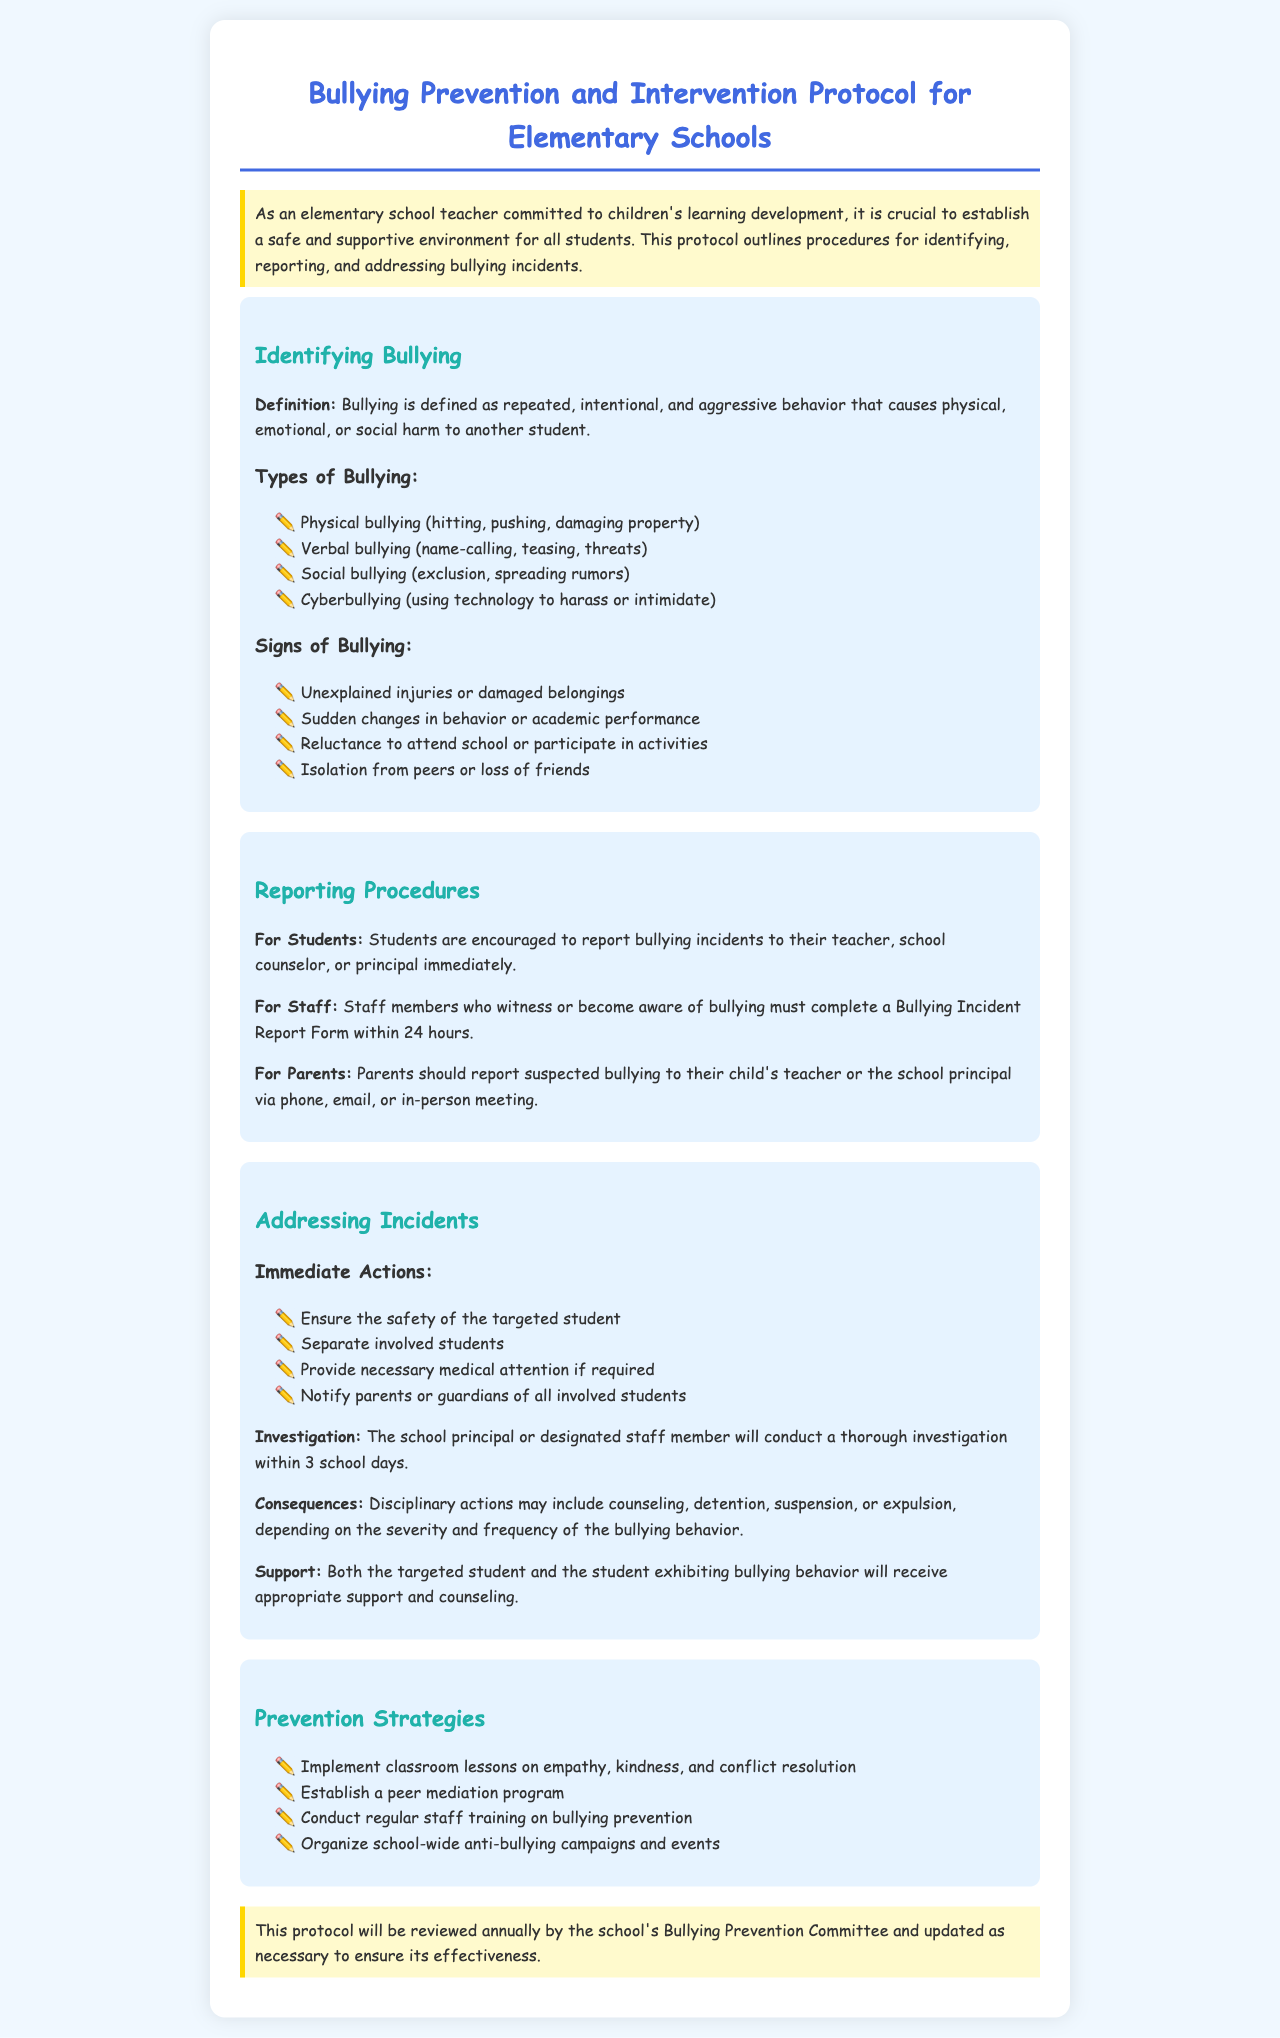What is the definition of bullying? The definition of bullying is stated in the document, highlighting that it involves repeated, intentional, and aggressive behavior causing harm to another student.
Answer: Repeated, intentional, and aggressive behavior What are the four types of bullying listed? The document specifies four types of bullying that need to be recognized.
Answer: Physical, verbal, social, cyberbullying Who should students report bullying incidents to? The document outlines the reporting channels for students experiencing bullying incidents.
Answer: Teacher, school counselor, or principal What is the time frame for staff to complete a Bullying Incident Report Form? The document mentions a specific time frame for staff action regarding reporting bullying incidents.
Answer: 24 hours What are the immediate actions to ensure safety? The document lists immediate actions to be taken when bullying is detected to secure the targeted student.
Answer: Ensure safety, separate students, provide medical attention, notify parents How many school days does the investigation take? The document provides a specific time frame for the investigation of bullying incidents.
Answer: 3 school days What are two prevention strategies suggested in the document? The document includes various strategies for preventing bullying in schools, focusing on education and support.
Answer: Classroom lessons on empathy, peer mediation program What is the role of the Bullying Prevention Committee? The document describes the purpose of the Bullying Prevention Committee concerning the policy protocol.
Answer: Review annually and update What type of behavior can lead to suspension as a consequence? The document discusses possible consequences tied to the severity and frequency of bullying behavior.
Answer: Severe and frequent bullying behavior 